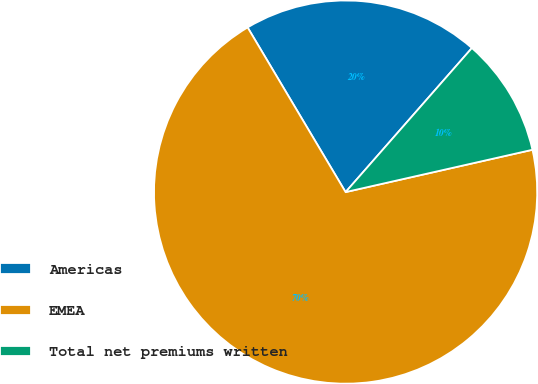<chart> <loc_0><loc_0><loc_500><loc_500><pie_chart><fcel>Americas<fcel>EMEA<fcel>Total net premiums written<nl><fcel>20.0%<fcel>70.0%<fcel>10.0%<nl></chart> 